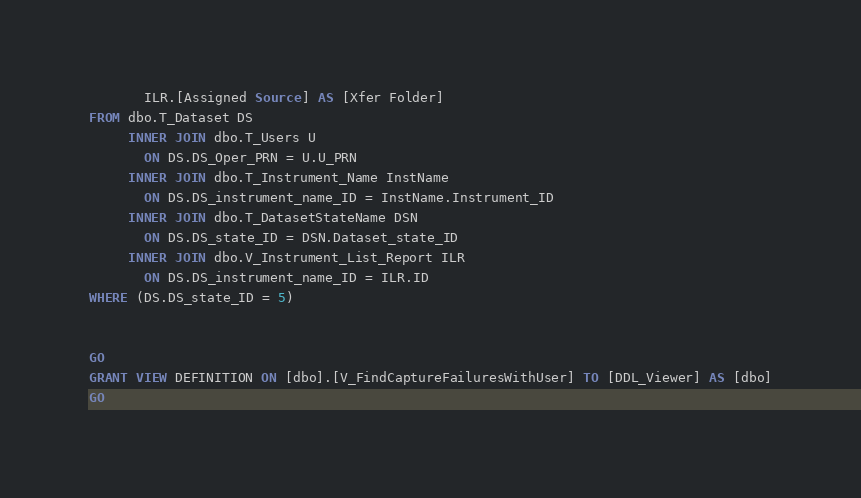Convert code to text. <code><loc_0><loc_0><loc_500><loc_500><_SQL_>       ILR.[Assigned Source] AS [Xfer Folder]
FROM dbo.T_Dataset DS
     INNER JOIN dbo.T_Users U
       ON DS.DS_Oper_PRN = U.U_PRN
     INNER JOIN dbo.T_Instrument_Name InstName
       ON DS.DS_instrument_name_ID = InstName.Instrument_ID
     INNER JOIN dbo.T_DatasetStateName DSN
       ON DS.DS_state_ID = DSN.Dataset_state_ID
     INNER JOIN dbo.V_Instrument_List_Report ILR
       ON DS.DS_instrument_name_ID = ILR.ID
WHERE (DS.DS_state_ID = 5)


GO
GRANT VIEW DEFINITION ON [dbo].[V_FindCaptureFailuresWithUser] TO [DDL_Viewer] AS [dbo]
GO
</code> 